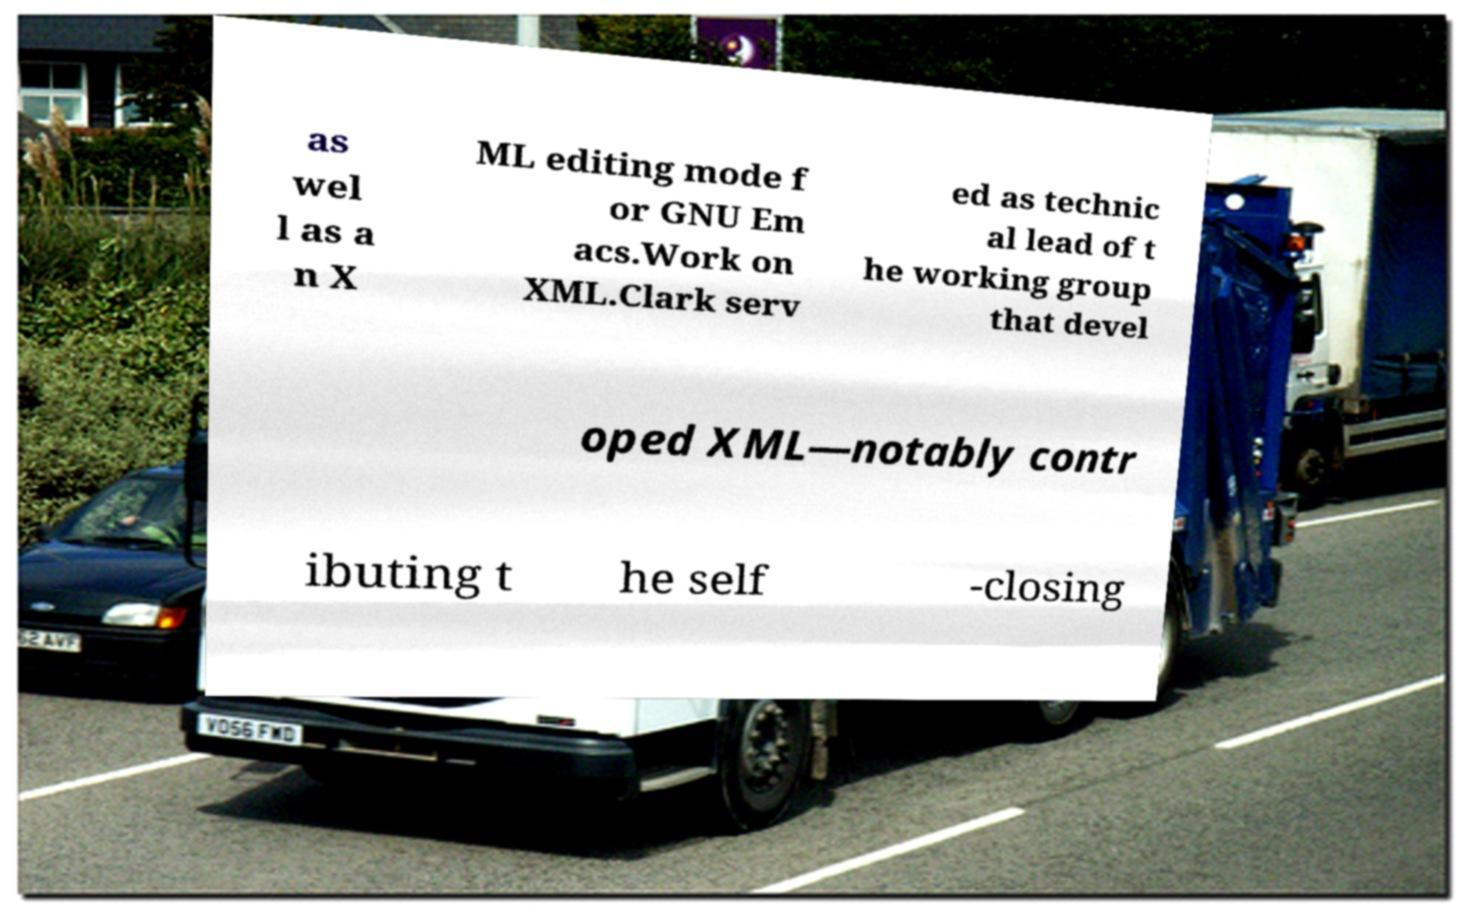There's text embedded in this image that I need extracted. Can you transcribe it verbatim? as wel l as a n X ML editing mode f or GNU Em acs.Work on XML.Clark serv ed as technic al lead of t he working group that devel oped XML—notably contr ibuting t he self -closing 